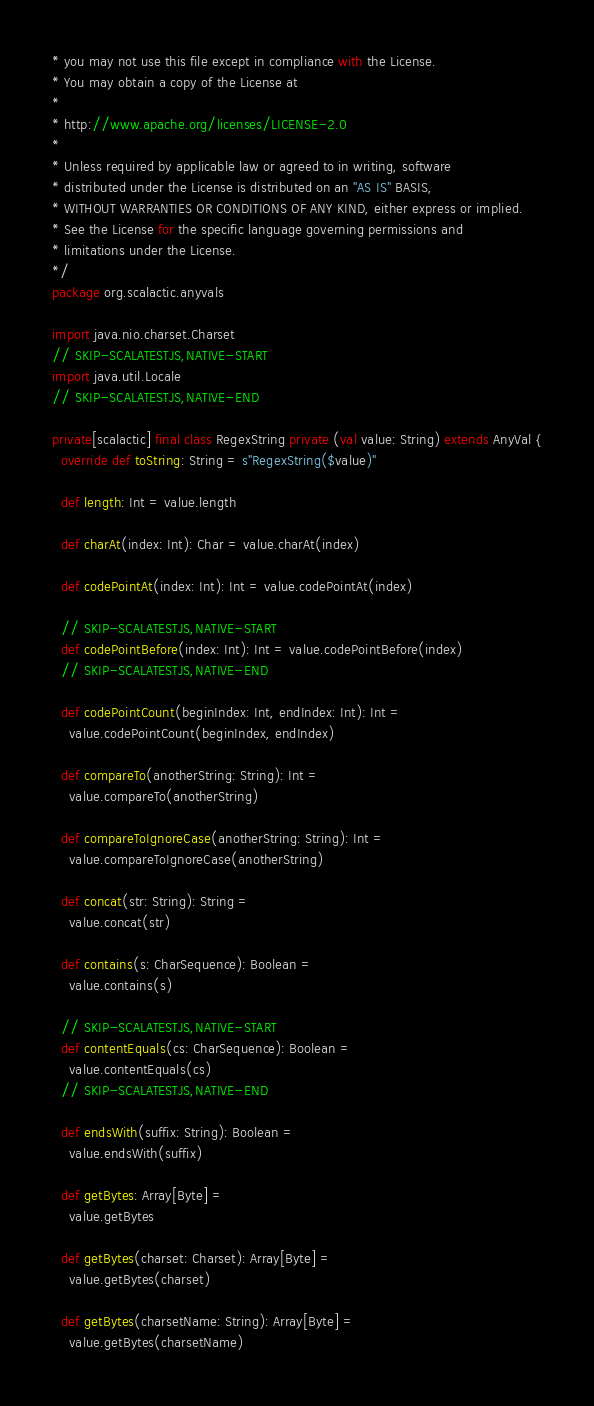Convert code to text. <code><loc_0><loc_0><loc_500><loc_500><_Scala_>* you may not use this file except in compliance with the License.
* You may obtain a copy of the License at
*
* http://www.apache.org/licenses/LICENSE-2.0
*
* Unless required by applicable law or agreed to in writing, software
* distributed under the License is distributed on an "AS IS" BASIS,
* WITHOUT WARRANTIES OR CONDITIONS OF ANY KIND, either express or implied.
* See the License for the specific language governing permissions and
* limitations under the License.
*/
package org.scalactic.anyvals

import java.nio.charset.Charset
// SKIP-SCALATESTJS,NATIVE-START
import java.util.Locale
// SKIP-SCALATESTJS,NATIVE-END

private[scalactic] final class RegexString private (val value: String) extends AnyVal {
  override def toString: String = s"RegexString($value)"

  def length: Int = value.length

  def charAt(index: Int): Char = value.charAt(index)

  def codePointAt(index: Int): Int = value.codePointAt(index)

  // SKIP-SCALATESTJS,NATIVE-START
  def codePointBefore(index: Int): Int = value.codePointBefore(index)
  // SKIP-SCALATESTJS,NATIVE-END

  def codePointCount(beginIndex: Int, endIndex: Int): Int =
    value.codePointCount(beginIndex, endIndex)

  def compareTo(anotherString: String): Int =
    value.compareTo(anotherString)

  def compareToIgnoreCase(anotherString: String): Int =
    value.compareToIgnoreCase(anotherString)

  def concat(str: String): String =
    value.concat(str)

  def contains(s: CharSequence): Boolean =
    value.contains(s)

  // SKIP-SCALATESTJS,NATIVE-START
  def contentEquals(cs: CharSequence): Boolean =
    value.contentEquals(cs)
  // SKIP-SCALATESTJS,NATIVE-END

  def endsWith(suffix: String): Boolean =
    value.endsWith(suffix)

  def getBytes: Array[Byte] =
    value.getBytes

  def getBytes(charset: Charset): Array[Byte] =
    value.getBytes(charset)

  def getBytes(charsetName: String): Array[Byte] =
    value.getBytes(charsetName)
</code> 